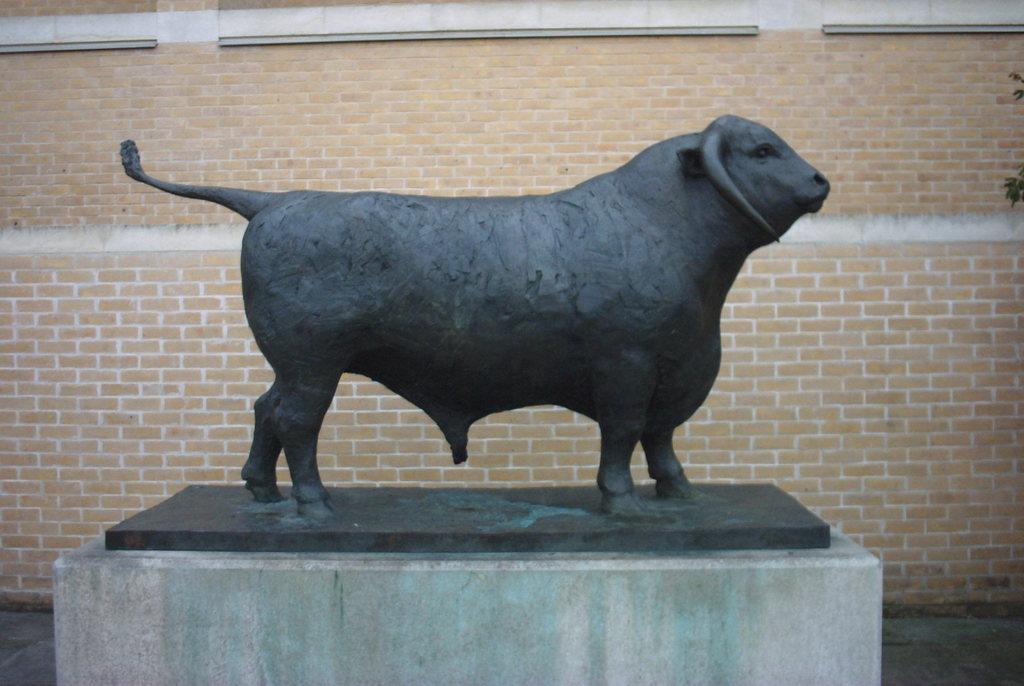What is the main subject of the image? There is a depiction of an animal in the image. What can be seen in the background of the image? There is a brick wall in the background of the image. What type of surface is visible in the image? There is a path visible in the image. What type of vegetation is present in the image? Leaves are present in the image. Where can the toys be found in the image? There are no toys present in the image. What is the animal drawing with chalk in the image? The image does not depict the animal using chalk or drawing anything. 